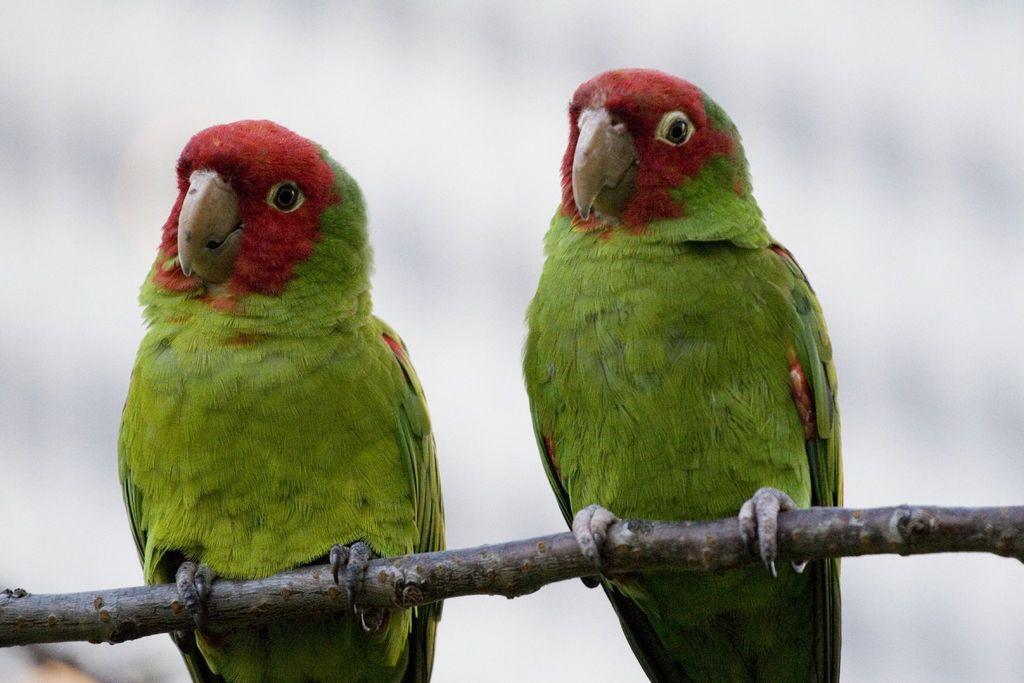In one or two sentences, can you explain what this image depicts? In this image I can see two parrots are on a branch. The background of the image is blurred. 